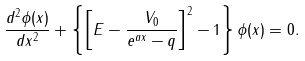<formula> <loc_0><loc_0><loc_500><loc_500>\frac { d ^ { 2 } \phi ( x ) } { d x ^ { 2 } } + \left \{ \left [ E - \frac { V _ { 0 } } { e ^ { a x } - q } \right ] ^ { 2 } - 1 \right \} \phi ( x ) = 0 .</formula> 